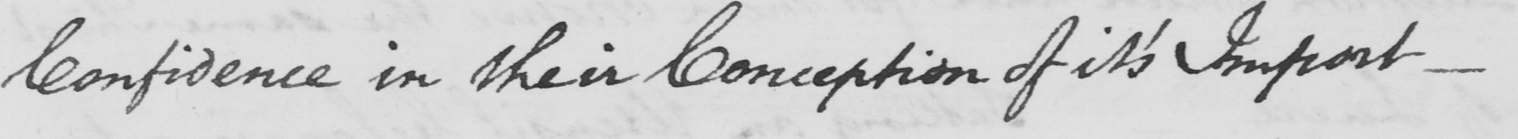Can you tell me what this handwritten text says? Confidence in their Conception of it ' s Import _ 